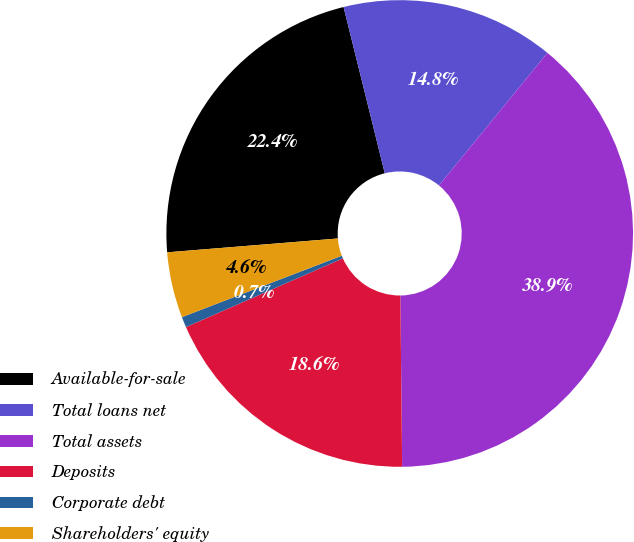<chart> <loc_0><loc_0><loc_500><loc_500><pie_chart><fcel>Available-for-sale<fcel>Total loans net<fcel>Total assets<fcel>Deposits<fcel>Corporate debt<fcel>Shareholders' equity<nl><fcel>22.42%<fcel>14.78%<fcel>38.92%<fcel>18.6%<fcel>0.73%<fcel>4.55%<nl></chart> 